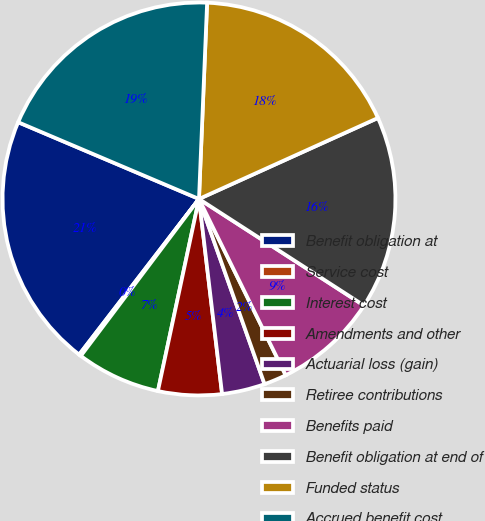Convert chart. <chart><loc_0><loc_0><loc_500><loc_500><pie_chart><fcel>Benefit obligation at<fcel>Service cost<fcel>Interest cost<fcel>Amendments and other<fcel>Actuarial loss (gain)<fcel>Retiree contributions<fcel>Benefits paid<fcel>Benefit obligation at end of<fcel>Funded status<fcel>Accrued benefit cost<nl><fcel>20.95%<fcel>0.17%<fcel>6.92%<fcel>5.23%<fcel>3.54%<fcel>1.86%<fcel>8.6%<fcel>15.89%<fcel>17.58%<fcel>19.27%<nl></chart> 